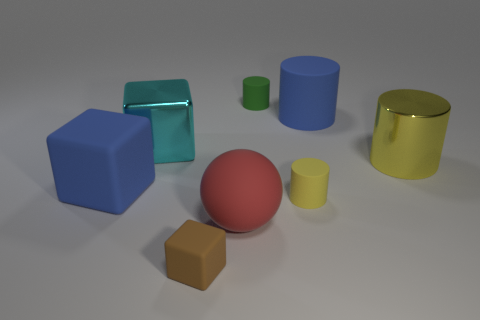Which object in the image is the largest and what color is it? The largest object in the image is the blue block at the center. Its prominent size overshadows the other shapes surrounding it, and it has a distinct, soothing blue color that resonates with a sense of calm. 